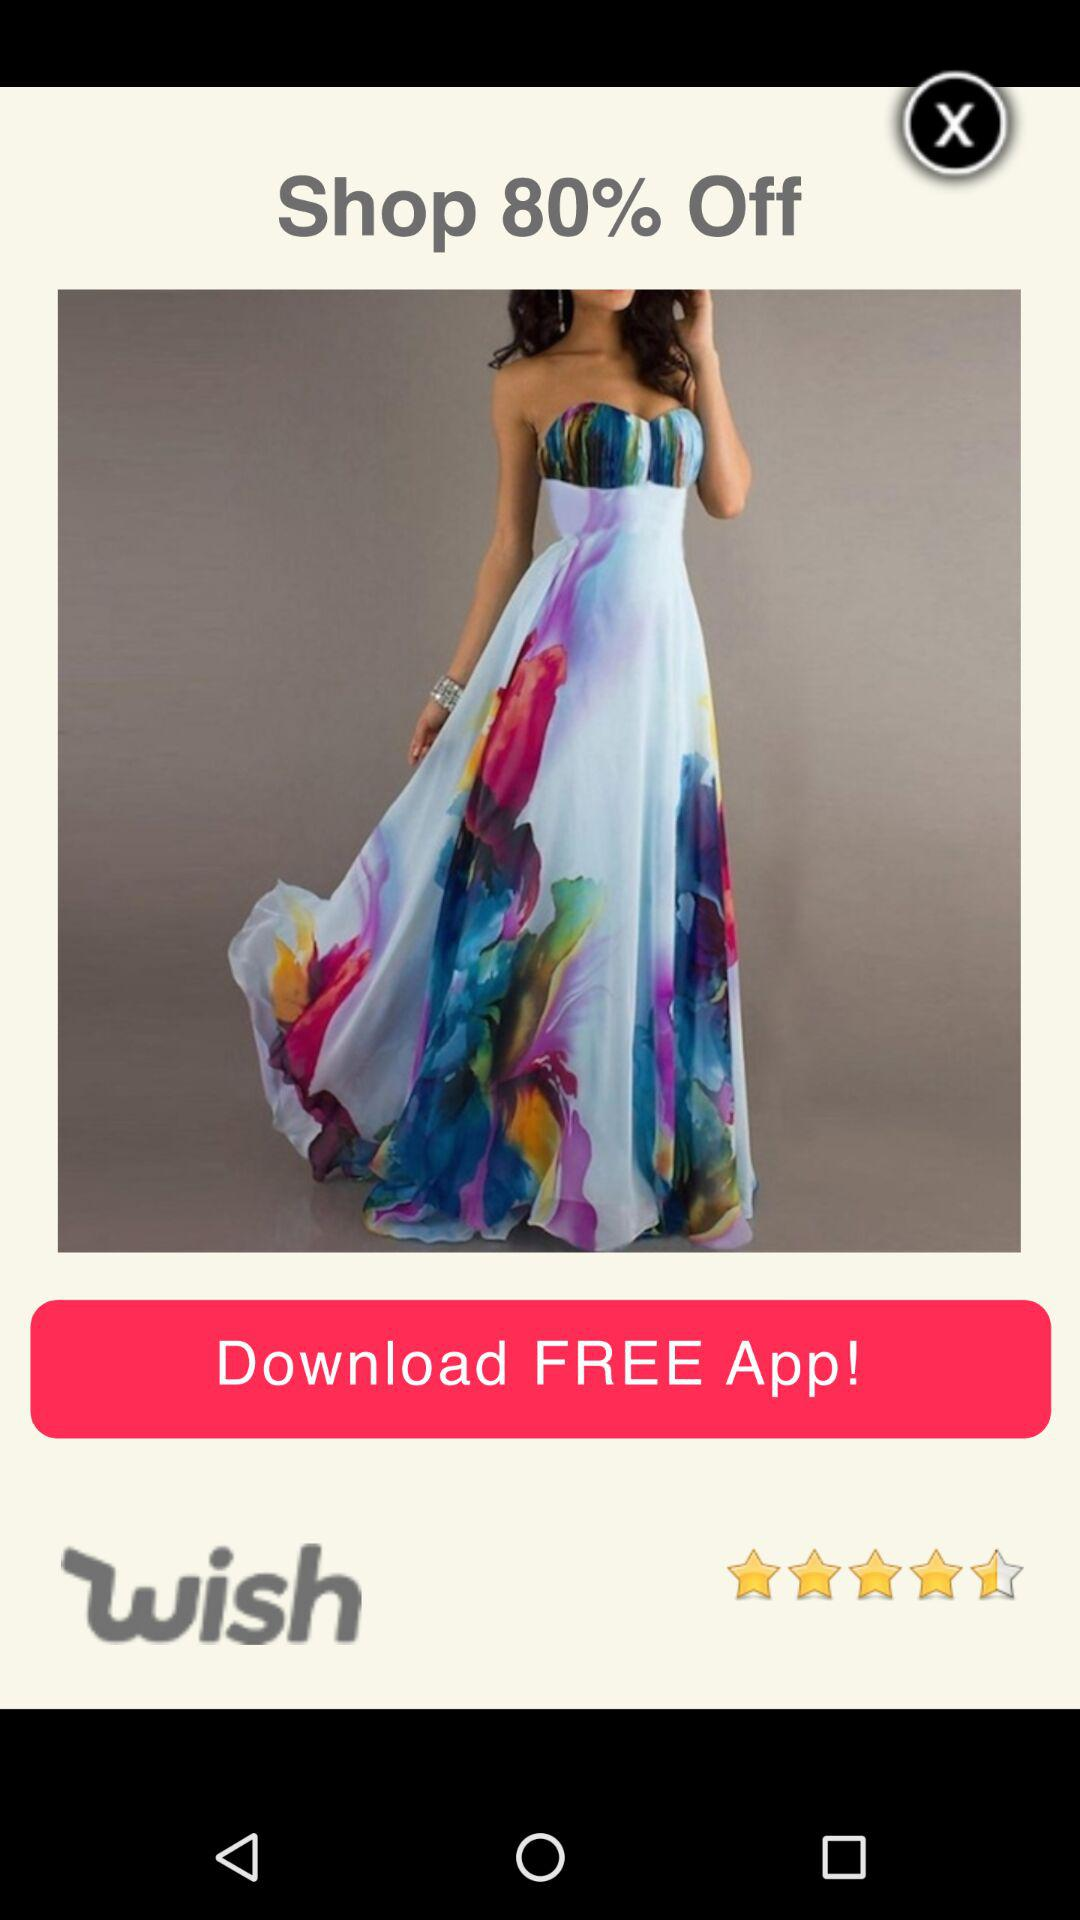How many percent off is the sale?
Answer the question using a single word or phrase. 80% 